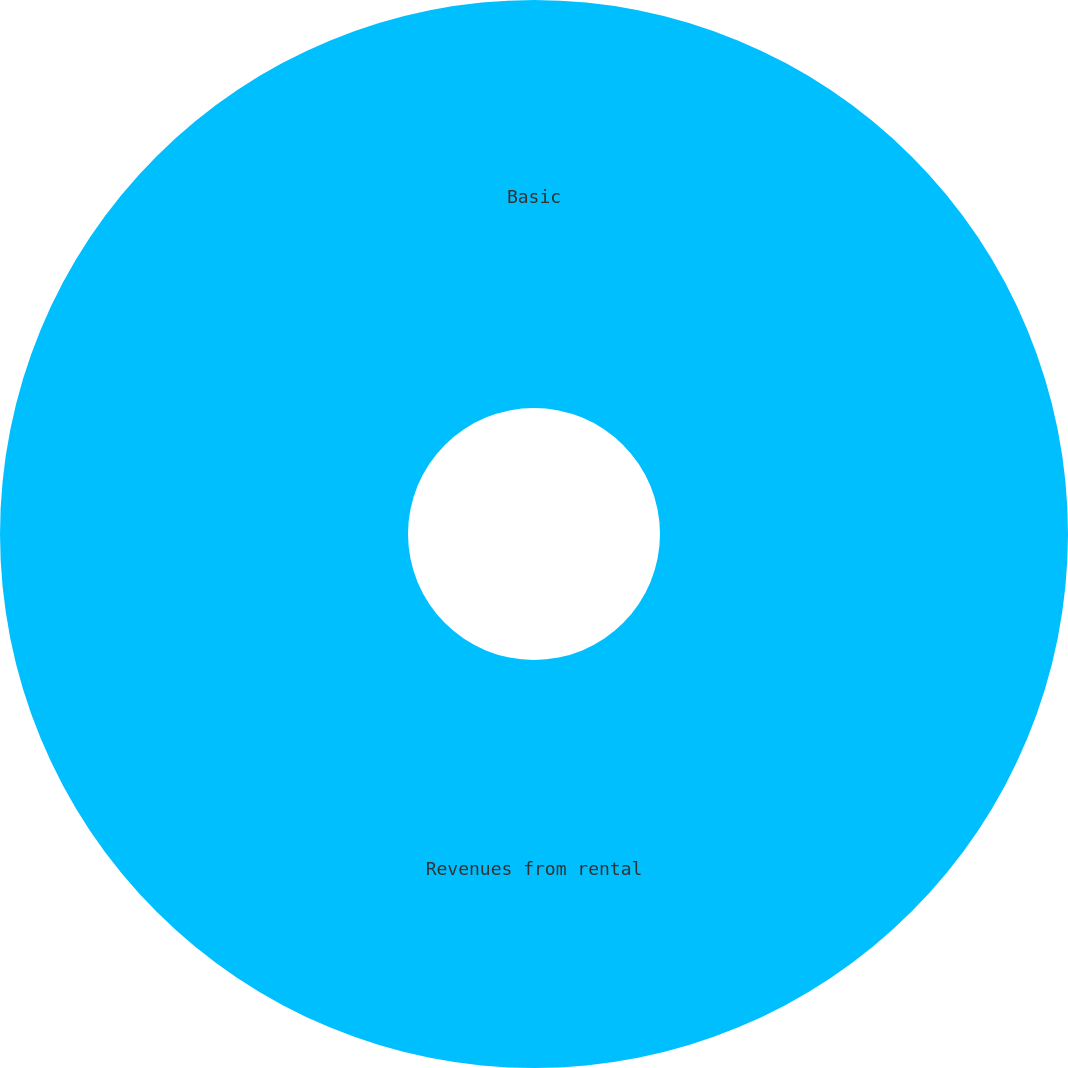Convert chart to OTSL. <chart><loc_0><loc_0><loc_500><loc_500><pie_chart><fcel>Revenues from rental<fcel>Basic<nl><fcel>100.0%<fcel>0.0%<nl></chart> 